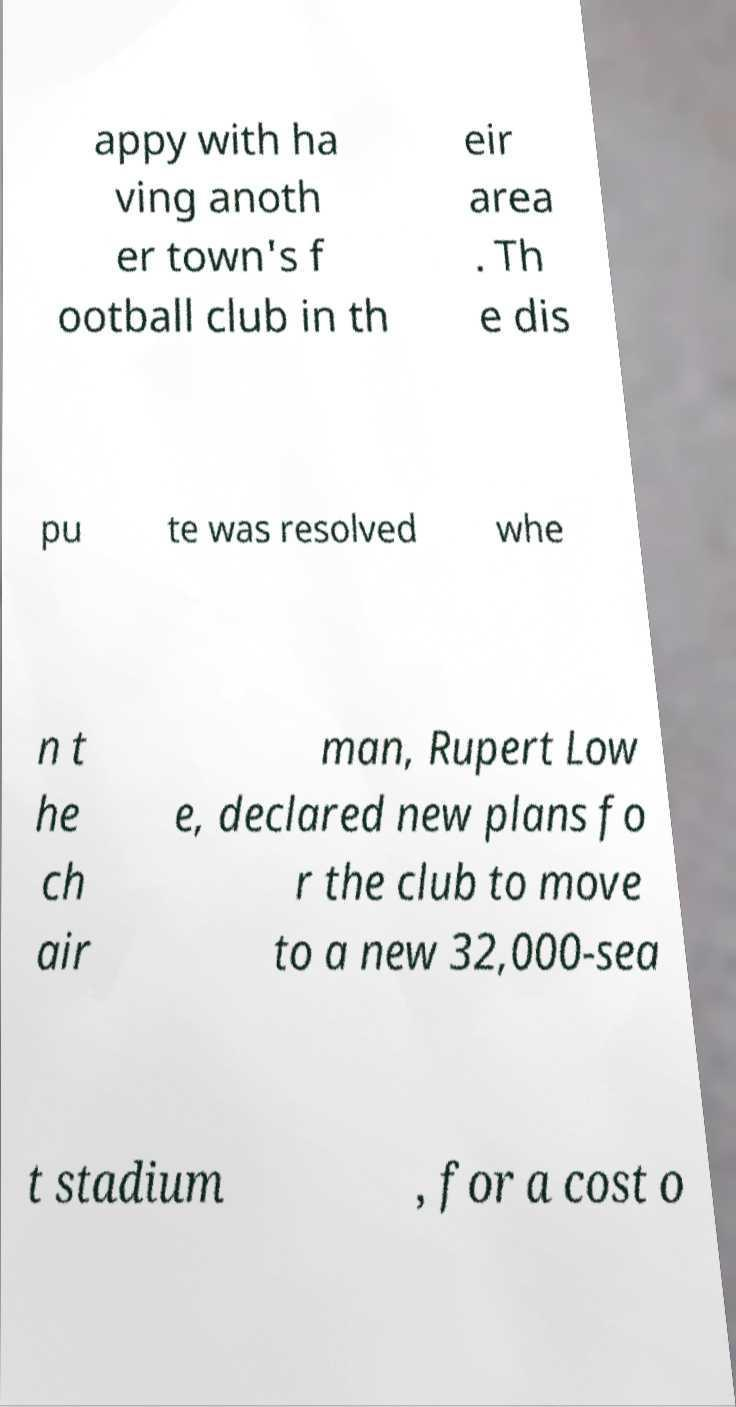Could you assist in decoding the text presented in this image and type it out clearly? appy with ha ving anoth er town's f ootball club in th eir area . Th e dis pu te was resolved whe n t he ch air man, Rupert Low e, declared new plans fo r the club to move to a new 32,000-sea t stadium , for a cost o 